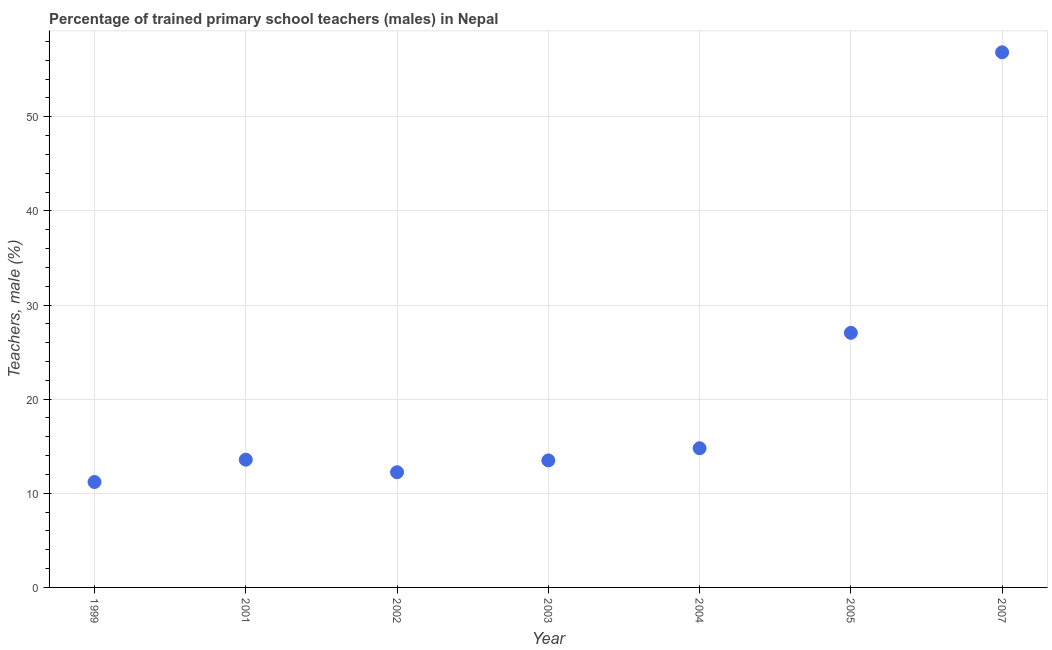What is the percentage of trained male teachers in 2002?
Your answer should be very brief. 12.24. Across all years, what is the maximum percentage of trained male teachers?
Give a very brief answer. 56.85. Across all years, what is the minimum percentage of trained male teachers?
Keep it short and to the point. 11.2. What is the sum of the percentage of trained male teachers?
Ensure brevity in your answer.  149.18. What is the difference between the percentage of trained male teachers in 2001 and 2007?
Ensure brevity in your answer.  -43.27. What is the average percentage of trained male teachers per year?
Make the answer very short. 21.31. What is the median percentage of trained male teachers?
Make the answer very short. 13.57. In how many years, is the percentage of trained male teachers greater than 28 %?
Keep it short and to the point. 1. What is the ratio of the percentage of trained male teachers in 1999 to that in 2007?
Your response must be concise. 0.2. Is the difference between the percentage of trained male teachers in 2001 and 2003 greater than the difference between any two years?
Provide a succinct answer. No. What is the difference between the highest and the second highest percentage of trained male teachers?
Provide a succinct answer. 29.8. Is the sum of the percentage of trained male teachers in 2001 and 2003 greater than the maximum percentage of trained male teachers across all years?
Offer a very short reply. No. What is the difference between the highest and the lowest percentage of trained male teachers?
Offer a terse response. 45.65. Does the percentage of trained male teachers monotonically increase over the years?
Offer a very short reply. No. How many dotlines are there?
Your answer should be compact. 1. Does the graph contain any zero values?
Your answer should be compact. No. What is the title of the graph?
Give a very brief answer. Percentage of trained primary school teachers (males) in Nepal. What is the label or title of the Y-axis?
Your answer should be very brief. Teachers, male (%). What is the Teachers, male (%) in 1999?
Make the answer very short. 11.2. What is the Teachers, male (%) in 2001?
Your answer should be very brief. 13.57. What is the Teachers, male (%) in 2002?
Your answer should be very brief. 12.24. What is the Teachers, male (%) in 2003?
Offer a terse response. 13.49. What is the Teachers, male (%) in 2004?
Your answer should be compact. 14.79. What is the Teachers, male (%) in 2005?
Keep it short and to the point. 27.04. What is the Teachers, male (%) in 2007?
Your answer should be compact. 56.85. What is the difference between the Teachers, male (%) in 1999 and 2001?
Keep it short and to the point. -2.37. What is the difference between the Teachers, male (%) in 1999 and 2002?
Your answer should be very brief. -1.04. What is the difference between the Teachers, male (%) in 1999 and 2003?
Provide a short and direct response. -2.3. What is the difference between the Teachers, male (%) in 1999 and 2004?
Your answer should be very brief. -3.59. What is the difference between the Teachers, male (%) in 1999 and 2005?
Provide a succinct answer. -15.85. What is the difference between the Teachers, male (%) in 1999 and 2007?
Provide a succinct answer. -45.65. What is the difference between the Teachers, male (%) in 2001 and 2002?
Ensure brevity in your answer.  1.34. What is the difference between the Teachers, male (%) in 2001 and 2003?
Keep it short and to the point. 0.08. What is the difference between the Teachers, male (%) in 2001 and 2004?
Provide a succinct answer. -1.21. What is the difference between the Teachers, male (%) in 2001 and 2005?
Your answer should be very brief. -13.47. What is the difference between the Teachers, male (%) in 2001 and 2007?
Your answer should be compact. -43.27. What is the difference between the Teachers, male (%) in 2002 and 2003?
Your answer should be compact. -1.26. What is the difference between the Teachers, male (%) in 2002 and 2004?
Provide a short and direct response. -2.55. What is the difference between the Teachers, male (%) in 2002 and 2005?
Give a very brief answer. -14.81. What is the difference between the Teachers, male (%) in 2002 and 2007?
Your response must be concise. -44.61. What is the difference between the Teachers, male (%) in 2003 and 2004?
Offer a terse response. -1.29. What is the difference between the Teachers, male (%) in 2003 and 2005?
Your response must be concise. -13.55. What is the difference between the Teachers, male (%) in 2003 and 2007?
Give a very brief answer. -43.35. What is the difference between the Teachers, male (%) in 2004 and 2005?
Keep it short and to the point. -12.26. What is the difference between the Teachers, male (%) in 2004 and 2007?
Your answer should be very brief. -42.06. What is the difference between the Teachers, male (%) in 2005 and 2007?
Give a very brief answer. -29.8. What is the ratio of the Teachers, male (%) in 1999 to that in 2001?
Offer a very short reply. 0.82. What is the ratio of the Teachers, male (%) in 1999 to that in 2002?
Your answer should be very brief. 0.92. What is the ratio of the Teachers, male (%) in 1999 to that in 2003?
Make the answer very short. 0.83. What is the ratio of the Teachers, male (%) in 1999 to that in 2004?
Keep it short and to the point. 0.76. What is the ratio of the Teachers, male (%) in 1999 to that in 2005?
Give a very brief answer. 0.41. What is the ratio of the Teachers, male (%) in 1999 to that in 2007?
Make the answer very short. 0.2. What is the ratio of the Teachers, male (%) in 2001 to that in 2002?
Make the answer very short. 1.11. What is the ratio of the Teachers, male (%) in 2001 to that in 2004?
Provide a short and direct response. 0.92. What is the ratio of the Teachers, male (%) in 2001 to that in 2005?
Offer a terse response. 0.5. What is the ratio of the Teachers, male (%) in 2001 to that in 2007?
Provide a short and direct response. 0.24. What is the ratio of the Teachers, male (%) in 2002 to that in 2003?
Make the answer very short. 0.91. What is the ratio of the Teachers, male (%) in 2002 to that in 2004?
Give a very brief answer. 0.83. What is the ratio of the Teachers, male (%) in 2002 to that in 2005?
Your answer should be very brief. 0.45. What is the ratio of the Teachers, male (%) in 2002 to that in 2007?
Provide a short and direct response. 0.21. What is the ratio of the Teachers, male (%) in 2003 to that in 2005?
Offer a terse response. 0.5. What is the ratio of the Teachers, male (%) in 2003 to that in 2007?
Keep it short and to the point. 0.24. What is the ratio of the Teachers, male (%) in 2004 to that in 2005?
Offer a very short reply. 0.55. What is the ratio of the Teachers, male (%) in 2004 to that in 2007?
Your answer should be compact. 0.26. What is the ratio of the Teachers, male (%) in 2005 to that in 2007?
Keep it short and to the point. 0.48. 